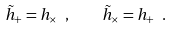Convert formula to latex. <formula><loc_0><loc_0><loc_500><loc_500>\tilde { h } _ { + } = h _ { \times } \ , \quad \tilde { h } _ { \times } = h _ { + } \ .</formula> 